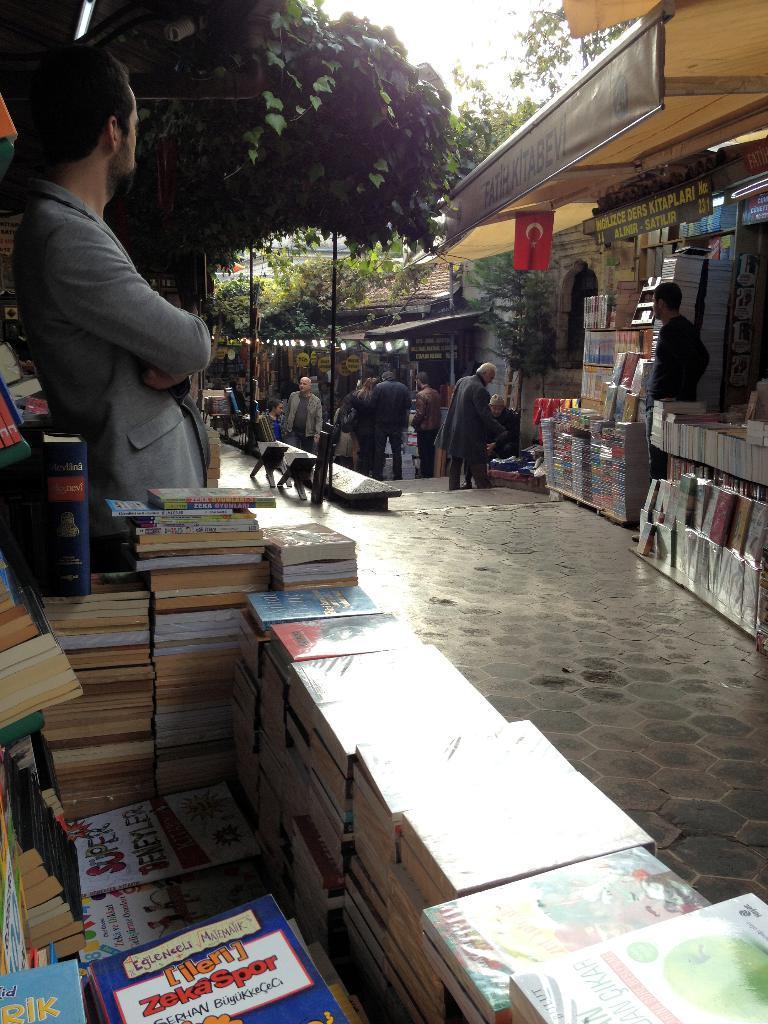How would you summarize this image in a sentence or two? In this picture there are books at the bottom side of the image and there is a boy who is standing on the left side of the image and there are stalls and people in the image and there are trees in the background area of the image. 